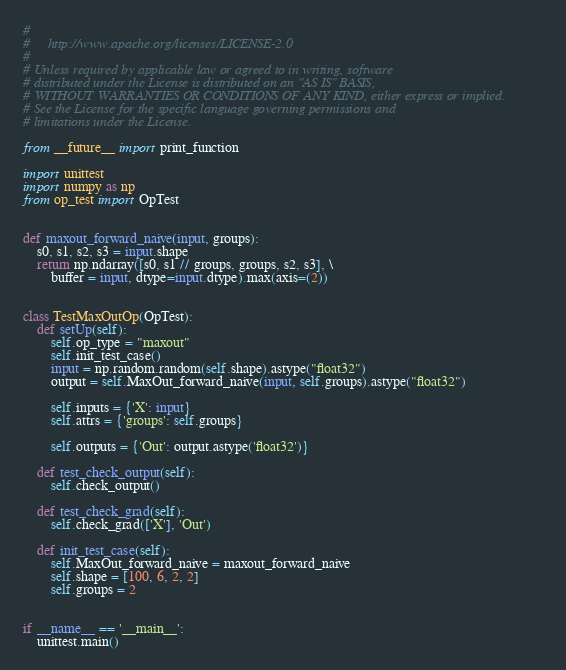Convert code to text. <code><loc_0><loc_0><loc_500><loc_500><_Python_>#
#     http://www.apache.org/licenses/LICENSE-2.0
#
# Unless required by applicable law or agreed to in writing, software
# distributed under the License is distributed on an "AS IS" BASIS,
# WITHOUT WARRANTIES OR CONDITIONS OF ANY KIND, either express or implied.
# See the License for the specific language governing permissions and
# limitations under the License.

from __future__ import print_function

import unittest
import numpy as np
from op_test import OpTest


def maxout_forward_naive(input, groups):
    s0, s1, s2, s3 = input.shape
    return np.ndarray([s0, s1 // groups, groups, s2, s3], \
        buffer = input, dtype=input.dtype).max(axis=(2))


class TestMaxOutOp(OpTest):
    def setUp(self):
        self.op_type = "maxout"
        self.init_test_case()
        input = np.random.random(self.shape).astype("float32")
        output = self.MaxOut_forward_naive(input, self.groups).astype("float32")

        self.inputs = {'X': input}
        self.attrs = {'groups': self.groups}

        self.outputs = {'Out': output.astype('float32')}

    def test_check_output(self):
        self.check_output()

    def test_check_grad(self):
        self.check_grad(['X'], 'Out')

    def init_test_case(self):
        self.MaxOut_forward_naive = maxout_forward_naive
        self.shape = [100, 6, 2, 2]
        self.groups = 2


if __name__ == '__main__':
    unittest.main()
</code> 